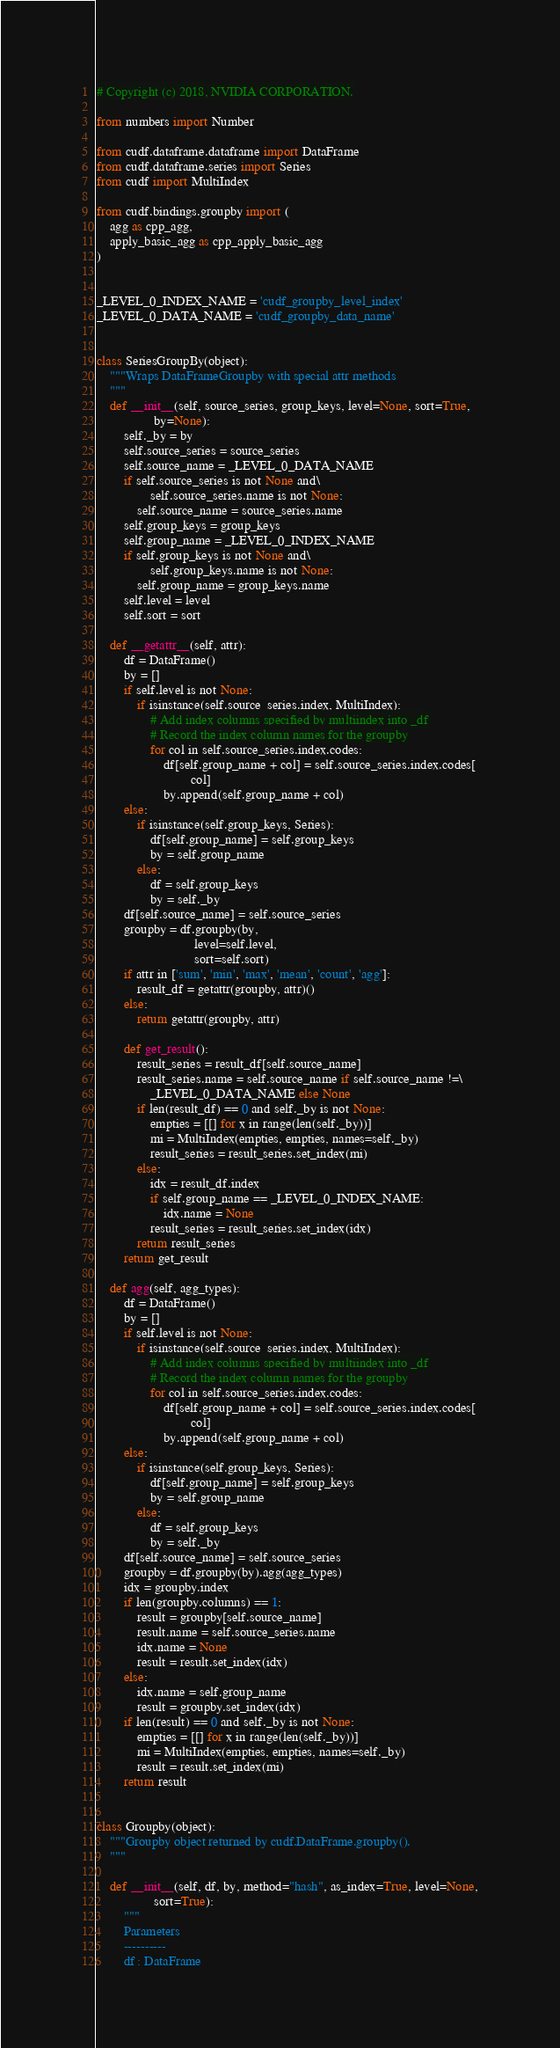Convert code to text. <code><loc_0><loc_0><loc_500><loc_500><_Python_># Copyright (c) 2018, NVIDIA CORPORATION.

from numbers import Number

from cudf.dataframe.dataframe import DataFrame
from cudf.dataframe.series import Series
from cudf import MultiIndex

from cudf.bindings.groupby import (
    agg as cpp_agg,
    apply_basic_agg as cpp_apply_basic_agg
)


_LEVEL_0_INDEX_NAME = 'cudf_groupby_level_index'
_LEVEL_0_DATA_NAME = 'cudf_groupby_data_name'


class SeriesGroupBy(object):
    """Wraps DataFrameGroupby with special attr methods
    """
    def __init__(self, source_series, group_keys, level=None, sort=True,
                 by=None):
        self._by = by
        self.source_series = source_series
        self.source_name = _LEVEL_0_DATA_NAME
        if self.source_series is not None and\
                self.source_series.name is not None:
            self.source_name = source_series.name
        self.group_keys = group_keys
        self.group_name = _LEVEL_0_INDEX_NAME
        if self.group_keys is not None and\
                self.group_keys.name is not None:
            self.group_name = group_keys.name
        self.level = level
        self.sort = sort

    def __getattr__(self, attr):
        df = DataFrame()
        by = []
        if self.level is not None:
            if isinstance(self.source_series.index, MultiIndex):
                # Add index columns specified by multiindex into _df
                # Record the index column names for the groupby
                for col in self.source_series.index.codes:
                    df[self.group_name + col] = self.source_series.index.codes[
                            col]
                    by.append(self.group_name + col)
        else:
            if isinstance(self.group_keys, Series):
                df[self.group_name] = self.group_keys
                by = self.group_name
            else:
                df = self.group_keys
                by = self._by
        df[self.source_name] = self.source_series
        groupby = df.groupby(by,
                             level=self.level,
                             sort=self.sort)
        if attr in ['sum', 'min', 'max', 'mean', 'count', 'agg']:
            result_df = getattr(groupby, attr)()
        else:
            return getattr(groupby, attr)

        def get_result():
            result_series = result_df[self.source_name]
            result_series.name = self.source_name if self.source_name !=\
                _LEVEL_0_DATA_NAME else None
            if len(result_df) == 0 and self._by is not None:
                empties = [[] for x in range(len(self._by))]
                mi = MultiIndex(empties, empties, names=self._by)
                result_series = result_series.set_index(mi)
            else:
                idx = result_df.index
                if self.group_name == _LEVEL_0_INDEX_NAME:
                    idx.name = None
                result_series = result_series.set_index(idx)
            return result_series
        return get_result

    def agg(self, agg_types):
        df = DataFrame()
        by = []
        if self.level is not None:
            if isinstance(self.source_series.index, MultiIndex):
                # Add index columns specified by multiindex into _df
                # Record the index column names for the groupby
                for col in self.source_series.index.codes:
                    df[self.group_name + col] = self.source_series.index.codes[
                            col]
                    by.append(self.group_name + col)
        else:
            if isinstance(self.group_keys, Series):
                df[self.group_name] = self.group_keys
                by = self.group_name
            else:
                df = self.group_keys
                by = self._by
        df[self.source_name] = self.source_series
        groupby = df.groupby(by).agg(agg_types)
        idx = groupby.index
        if len(groupby.columns) == 1:
            result = groupby[self.source_name]
            result.name = self.source_series.name
            idx.name = None
            result = result.set_index(idx)
        else:
            idx.name = self.group_name
            result = groupby.set_index(idx)
        if len(result) == 0 and self._by is not None:
            empties = [[] for x in range(len(self._by))]
            mi = MultiIndex(empties, empties, names=self._by)
            result = result.set_index(mi)
        return result


class Groupby(object):
    """Groupby object returned by cudf.DataFrame.groupby().
    """

    def __init__(self, df, by, method="hash", as_index=True, level=None,
                 sort=True):
        """
        Parameters
        ----------
        df : DataFrame</code> 